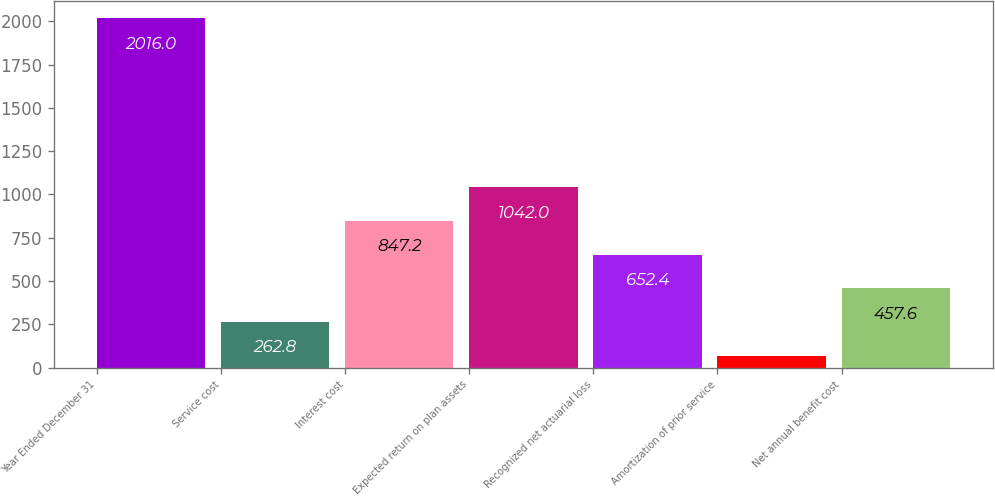<chart> <loc_0><loc_0><loc_500><loc_500><bar_chart><fcel>Year Ended December 31<fcel>Service cost<fcel>Interest cost<fcel>Expected return on plan assets<fcel>Recognized net actuarial loss<fcel>Amortization of prior service<fcel>Net annual benefit cost<nl><fcel>2016<fcel>262.8<fcel>847.2<fcel>1042<fcel>652.4<fcel>68<fcel>457.6<nl></chart> 